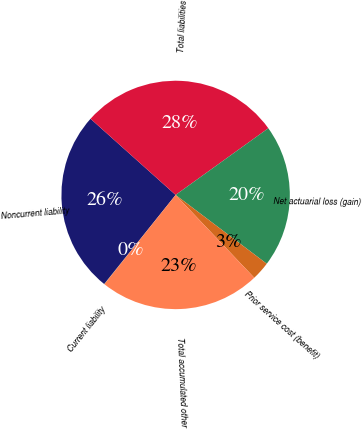Convert chart to OTSL. <chart><loc_0><loc_0><loc_500><loc_500><pie_chart><fcel>Current liability<fcel>Noncurrent liability<fcel>Total liabilities<fcel>Net actuarial loss (gain)<fcel>Prior service cost (benefit)<fcel>Total accumulated other<nl><fcel>0.04%<fcel>25.86%<fcel>28.45%<fcel>20.22%<fcel>2.62%<fcel>22.81%<nl></chart> 